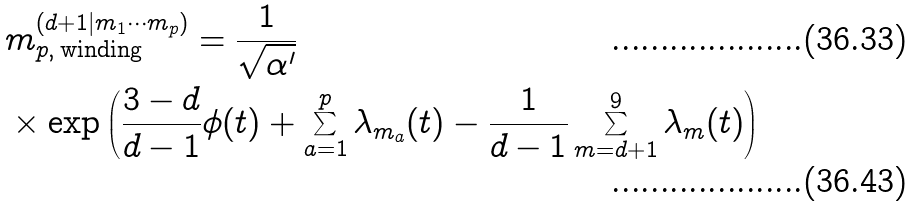<formula> <loc_0><loc_0><loc_500><loc_500>& m ^ { ( d + 1 | m _ { 1 } \cdots m _ { p } ) } _ { p , \, \text {winding} } = \frac { 1 } { \sqrt { \alpha ^ { \prime } } } \\ & \times \exp \left ( \frac { 3 - d } { d - 1 } \phi ( t ) + \sum _ { a = 1 } ^ { p } \lambda _ { m _ { a } } ( t ) - \frac { 1 } { d - 1 } \sum _ { m = d + 1 } ^ { 9 } \lambda _ { m } ( t ) \right )</formula> 